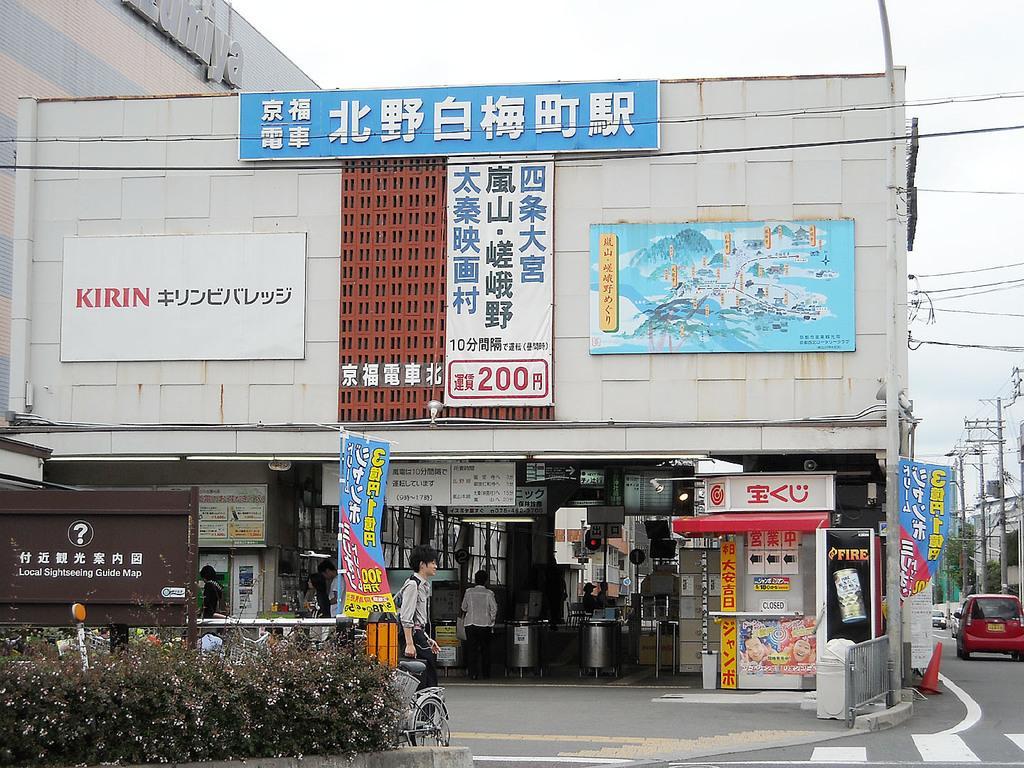In one or two sentences, can you explain what this image depicts? In this image I can see few buildings, boards, banners, few stores, current poles, wires, fencing, traffic cone, small plants and few vehicles on the road. I can see few people and the sky is in white color. 